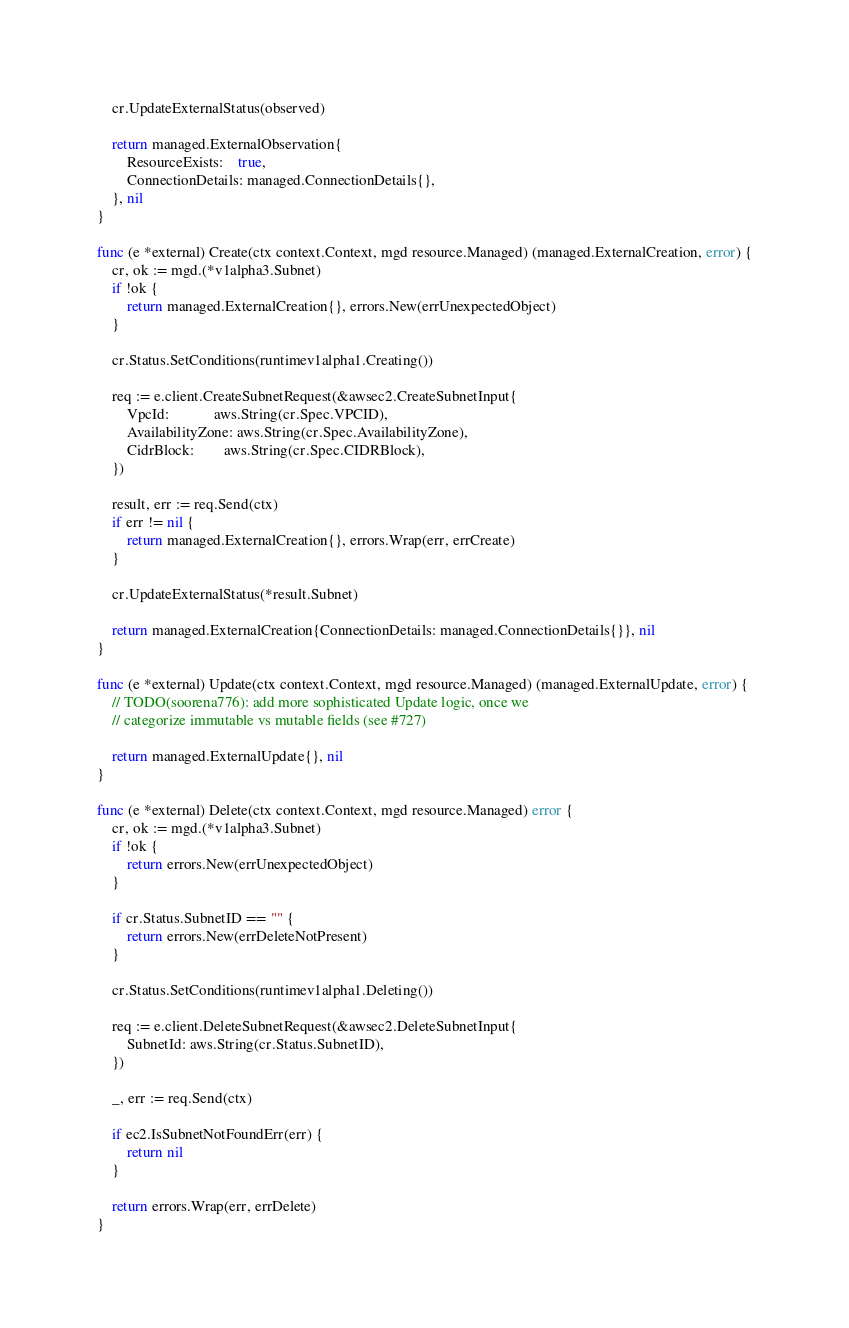<code> <loc_0><loc_0><loc_500><loc_500><_Go_>	cr.UpdateExternalStatus(observed)

	return managed.ExternalObservation{
		ResourceExists:    true,
		ConnectionDetails: managed.ConnectionDetails{},
	}, nil
}

func (e *external) Create(ctx context.Context, mgd resource.Managed) (managed.ExternalCreation, error) {
	cr, ok := mgd.(*v1alpha3.Subnet)
	if !ok {
		return managed.ExternalCreation{}, errors.New(errUnexpectedObject)
	}

	cr.Status.SetConditions(runtimev1alpha1.Creating())

	req := e.client.CreateSubnetRequest(&awsec2.CreateSubnetInput{
		VpcId:            aws.String(cr.Spec.VPCID),
		AvailabilityZone: aws.String(cr.Spec.AvailabilityZone),
		CidrBlock:        aws.String(cr.Spec.CIDRBlock),
	})

	result, err := req.Send(ctx)
	if err != nil {
		return managed.ExternalCreation{}, errors.Wrap(err, errCreate)
	}

	cr.UpdateExternalStatus(*result.Subnet)

	return managed.ExternalCreation{ConnectionDetails: managed.ConnectionDetails{}}, nil
}

func (e *external) Update(ctx context.Context, mgd resource.Managed) (managed.ExternalUpdate, error) {
	// TODO(soorena776): add more sophisticated Update logic, once we
	// categorize immutable vs mutable fields (see #727)

	return managed.ExternalUpdate{}, nil
}

func (e *external) Delete(ctx context.Context, mgd resource.Managed) error {
	cr, ok := mgd.(*v1alpha3.Subnet)
	if !ok {
		return errors.New(errUnexpectedObject)
	}

	if cr.Status.SubnetID == "" {
		return errors.New(errDeleteNotPresent)
	}

	cr.Status.SetConditions(runtimev1alpha1.Deleting())

	req := e.client.DeleteSubnetRequest(&awsec2.DeleteSubnetInput{
		SubnetId: aws.String(cr.Status.SubnetID),
	})

	_, err := req.Send(ctx)

	if ec2.IsSubnetNotFoundErr(err) {
		return nil
	}

	return errors.Wrap(err, errDelete)
}
</code> 